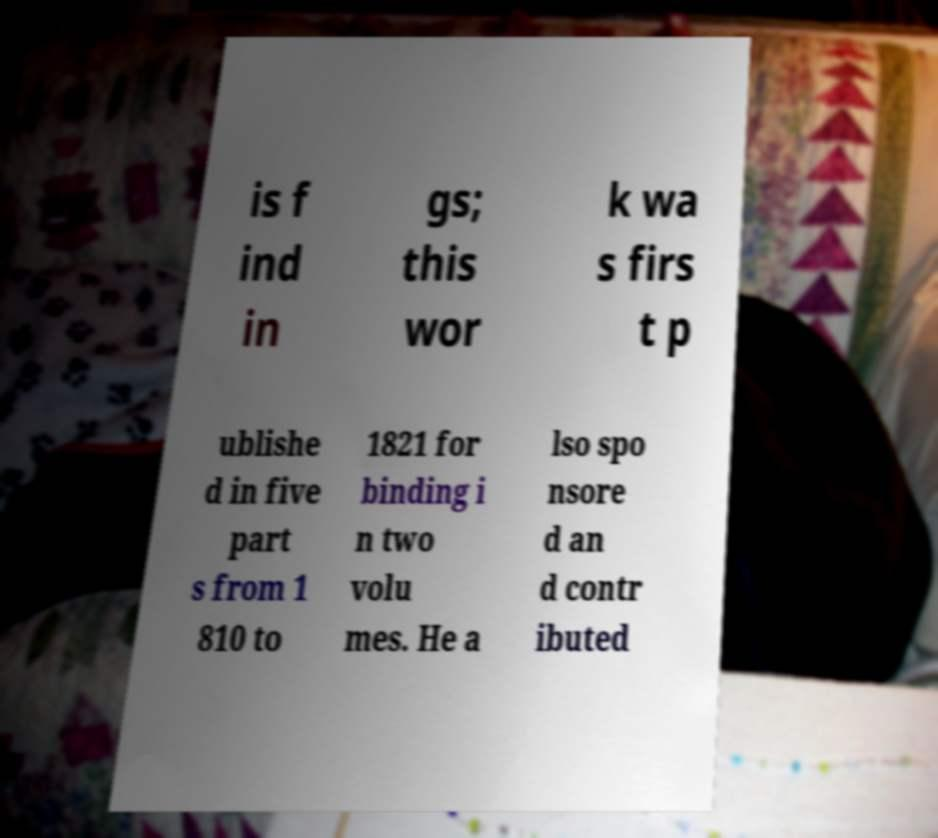There's text embedded in this image that I need extracted. Can you transcribe it verbatim? is f ind in gs; this wor k wa s firs t p ublishe d in five part s from 1 810 to 1821 for binding i n two volu mes. He a lso spo nsore d an d contr ibuted 